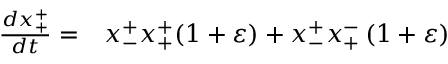Convert formula to latex. <formula><loc_0><loc_0><loc_500><loc_500>\begin{array} { r l } { \frac { d x _ { + } ^ { + } } { d t } = } & x _ { - } ^ { + } x _ { + } ^ { + } ( 1 + \varepsilon ) + x _ { - } ^ { + } x _ { + } ^ { - } \left ( 1 + \varepsilon \right ) } \end{array}</formula> 